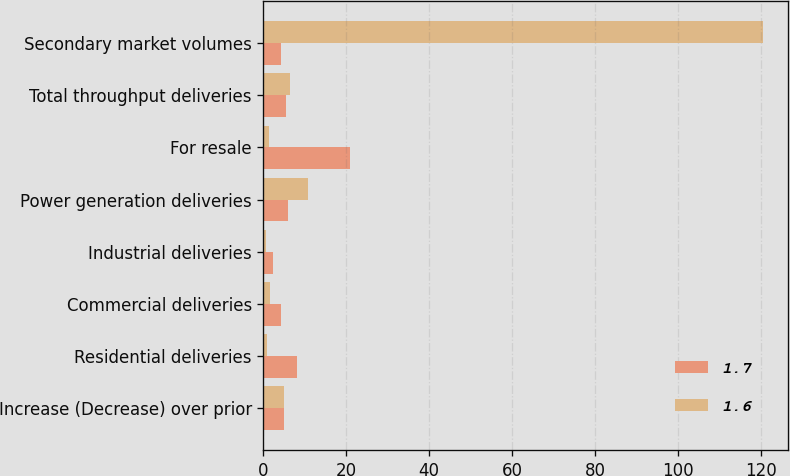Convert chart. <chart><loc_0><loc_0><loc_500><loc_500><stacked_bar_chart><ecel><fcel>Increase (Decrease) over prior<fcel>Residential deliveries<fcel>Commercial deliveries<fcel>Industrial deliveries<fcel>Power generation deliveries<fcel>For resale<fcel>Total throughput deliveries<fcel>Secondary market volumes<nl><fcel>1.7<fcel>4.85<fcel>8.1<fcel>4.3<fcel>2.2<fcel>5.8<fcel>20.9<fcel>5.4<fcel>4.2<nl><fcel>1.6<fcel>4.85<fcel>0.8<fcel>1.6<fcel>0.5<fcel>10.7<fcel>1.3<fcel>6.3<fcel>120.6<nl></chart> 